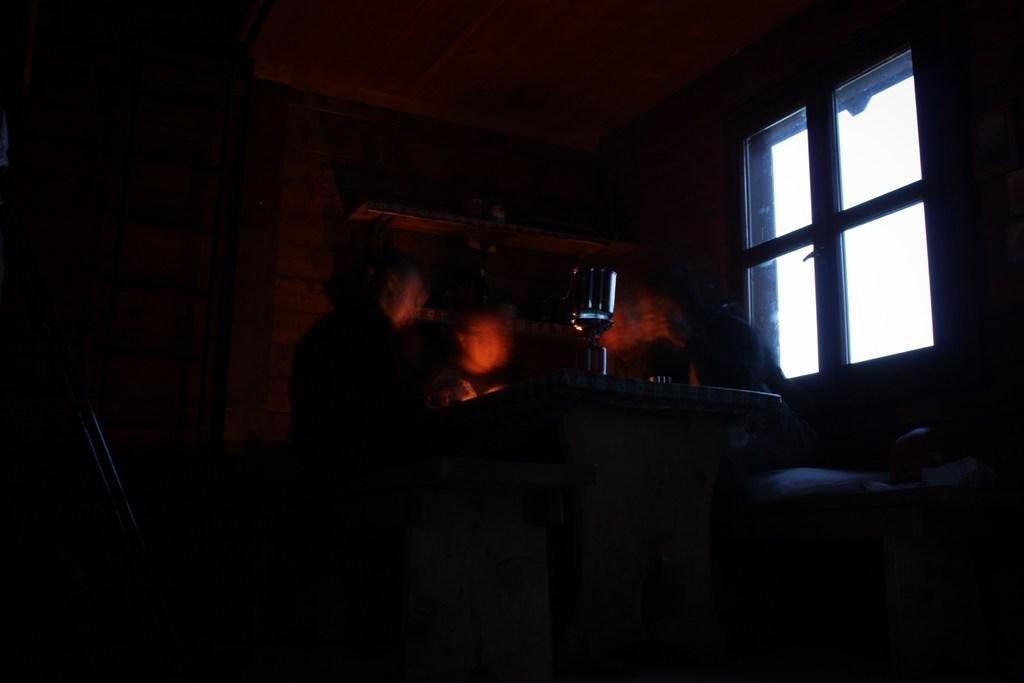Could you give a brief overview of what you see in this image? In this image I can see few persons standing, a window and I can see dark background. 